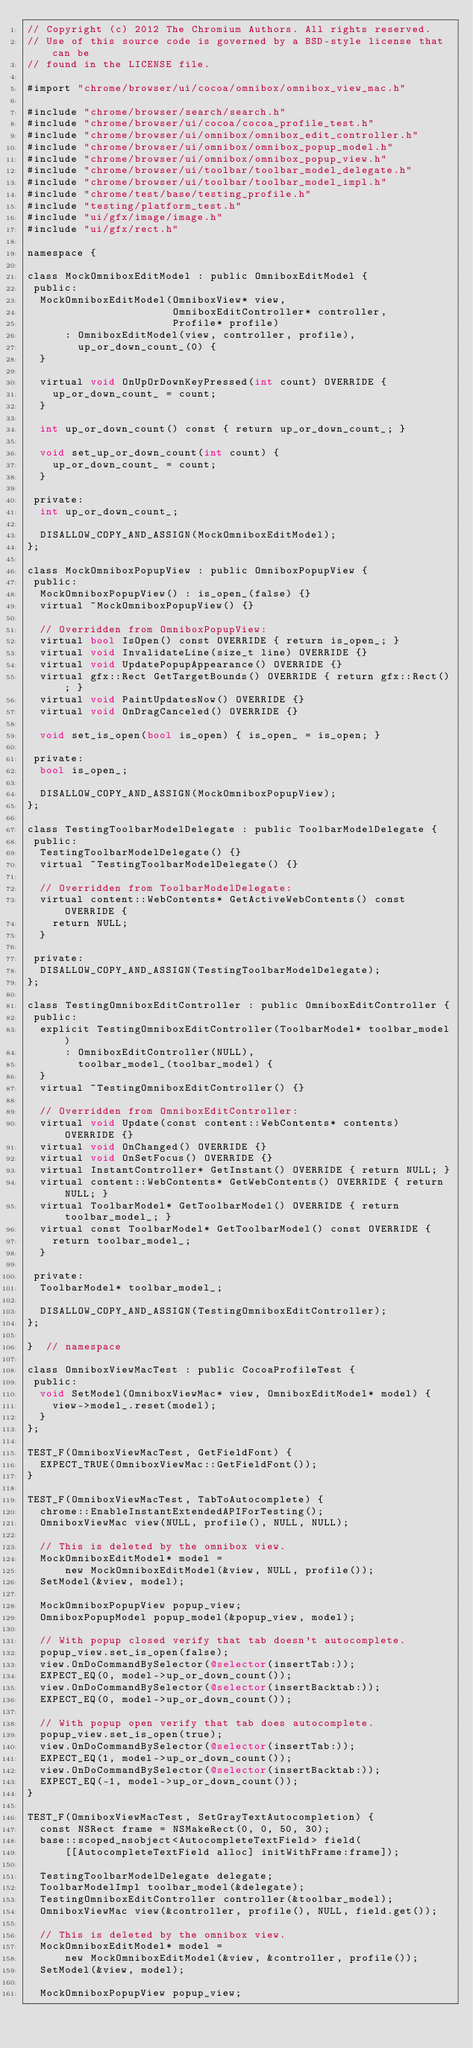<code> <loc_0><loc_0><loc_500><loc_500><_ObjectiveC_>// Copyright (c) 2012 The Chromium Authors. All rights reserved.
// Use of this source code is governed by a BSD-style license that can be
// found in the LICENSE file.

#import "chrome/browser/ui/cocoa/omnibox/omnibox_view_mac.h"

#include "chrome/browser/search/search.h"
#include "chrome/browser/ui/cocoa/cocoa_profile_test.h"
#include "chrome/browser/ui/omnibox/omnibox_edit_controller.h"
#include "chrome/browser/ui/omnibox/omnibox_popup_model.h"
#include "chrome/browser/ui/omnibox/omnibox_popup_view.h"
#include "chrome/browser/ui/toolbar/toolbar_model_delegate.h"
#include "chrome/browser/ui/toolbar/toolbar_model_impl.h"
#include "chrome/test/base/testing_profile.h"
#include "testing/platform_test.h"
#include "ui/gfx/image/image.h"
#include "ui/gfx/rect.h"

namespace {

class MockOmniboxEditModel : public OmniboxEditModel {
 public:
  MockOmniboxEditModel(OmniboxView* view,
                       OmniboxEditController* controller,
                       Profile* profile)
      : OmniboxEditModel(view, controller, profile),
        up_or_down_count_(0) {
  }

  virtual void OnUpOrDownKeyPressed(int count) OVERRIDE {
    up_or_down_count_ = count;
  }

  int up_or_down_count() const { return up_or_down_count_; }

  void set_up_or_down_count(int count) {
    up_or_down_count_ = count;
  }

 private:
  int up_or_down_count_;

  DISALLOW_COPY_AND_ASSIGN(MockOmniboxEditModel);
};

class MockOmniboxPopupView : public OmniboxPopupView {
 public:
  MockOmniboxPopupView() : is_open_(false) {}
  virtual ~MockOmniboxPopupView() {}

  // Overridden from OmniboxPopupView:
  virtual bool IsOpen() const OVERRIDE { return is_open_; }
  virtual void InvalidateLine(size_t line) OVERRIDE {}
  virtual void UpdatePopupAppearance() OVERRIDE {}
  virtual gfx::Rect GetTargetBounds() OVERRIDE { return gfx::Rect(); }
  virtual void PaintUpdatesNow() OVERRIDE {}
  virtual void OnDragCanceled() OVERRIDE {}

  void set_is_open(bool is_open) { is_open_ = is_open; }

 private:
  bool is_open_;

  DISALLOW_COPY_AND_ASSIGN(MockOmniboxPopupView);
};

class TestingToolbarModelDelegate : public ToolbarModelDelegate {
 public:
  TestingToolbarModelDelegate() {}
  virtual ~TestingToolbarModelDelegate() {}

  // Overridden from ToolbarModelDelegate:
  virtual content::WebContents* GetActiveWebContents() const OVERRIDE {
    return NULL;
  }

 private:
  DISALLOW_COPY_AND_ASSIGN(TestingToolbarModelDelegate);
};

class TestingOmniboxEditController : public OmniboxEditController {
 public:
  explicit TestingOmniboxEditController(ToolbarModel* toolbar_model)
      : OmniboxEditController(NULL),
        toolbar_model_(toolbar_model) {
  }
  virtual ~TestingOmniboxEditController() {}

  // Overridden from OmniboxEditController:
  virtual void Update(const content::WebContents* contents) OVERRIDE {}
  virtual void OnChanged() OVERRIDE {}
  virtual void OnSetFocus() OVERRIDE {}
  virtual InstantController* GetInstant() OVERRIDE { return NULL; }
  virtual content::WebContents* GetWebContents() OVERRIDE { return NULL; }
  virtual ToolbarModel* GetToolbarModel() OVERRIDE { return toolbar_model_; }
  virtual const ToolbarModel* GetToolbarModel() const OVERRIDE {
    return toolbar_model_;
  }

 private:
  ToolbarModel* toolbar_model_;

  DISALLOW_COPY_AND_ASSIGN(TestingOmniboxEditController);
};

}  // namespace

class OmniboxViewMacTest : public CocoaProfileTest {
 public:
  void SetModel(OmniboxViewMac* view, OmniboxEditModel* model) {
    view->model_.reset(model);
  }
};

TEST_F(OmniboxViewMacTest, GetFieldFont) {
  EXPECT_TRUE(OmniboxViewMac::GetFieldFont());
}

TEST_F(OmniboxViewMacTest, TabToAutocomplete) {
  chrome::EnableInstantExtendedAPIForTesting();
  OmniboxViewMac view(NULL, profile(), NULL, NULL);

  // This is deleted by the omnibox view.
  MockOmniboxEditModel* model =
      new MockOmniboxEditModel(&view, NULL, profile());
  SetModel(&view, model);

  MockOmniboxPopupView popup_view;
  OmniboxPopupModel popup_model(&popup_view, model);

  // With popup closed verify that tab doesn't autocomplete.
  popup_view.set_is_open(false);
  view.OnDoCommandBySelector(@selector(insertTab:));
  EXPECT_EQ(0, model->up_or_down_count());
  view.OnDoCommandBySelector(@selector(insertBacktab:));
  EXPECT_EQ(0, model->up_or_down_count());

  // With popup open verify that tab does autocomplete.
  popup_view.set_is_open(true);
  view.OnDoCommandBySelector(@selector(insertTab:));
  EXPECT_EQ(1, model->up_or_down_count());
  view.OnDoCommandBySelector(@selector(insertBacktab:));
  EXPECT_EQ(-1, model->up_or_down_count());
}

TEST_F(OmniboxViewMacTest, SetGrayTextAutocompletion) {
  const NSRect frame = NSMakeRect(0, 0, 50, 30);
  base::scoped_nsobject<AutocompleteTextField> field(
      [[AutocompleteTextField alloc] initWithFrame:frame]);

  TestingToolbarModelDelegate delegate;
  ToolbarModelImpl toolbar_model(&delegate);
  TestingOmniboxEditController controller(&toolbar_model);
  OmniboxViewMac view(&controller, profile(), NULL, field.get());

  // This is deleted by the omnibox view.
  MockOmniboxEditModel* model =
      new MockOmniboxEditModel(&view, &controller, profile());
  SetModel(&view, model);

  MockOmniboxPopupView popup_view;</code> 